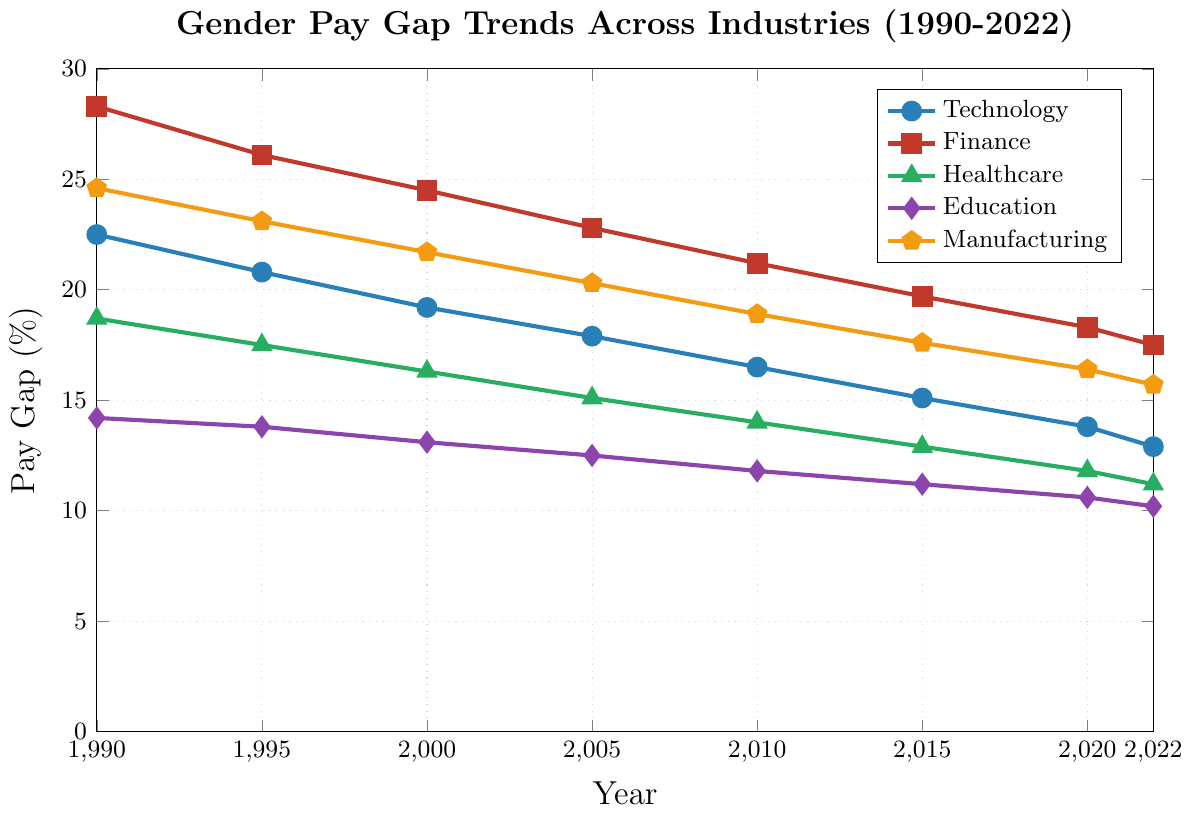What is the trend of the gender pay gap in the Technology industry from 1990 to 2022? The gender pay gap in the Technology industry shows a decreasing trend from 1990 to 2022. In 1990, the gap was 22.5%, which reduced to 12.9% in 2022. This indicates an improvement in closing the gender pay gap over the years.
Answer: Decreasing Which industry had the highest gender pay gap in 1990? By looking at the figure, the Finance industry had the highest gender pay gap in 1990 with a value of 28.3%.
Answer: Finance Compare the gender pay gap in the Education industry in 1990 and 2022. What is the difference? The gender pay gap in the Education industry was 14.2% in 1990 and 10.2% in 2022. The difference between these two values is 14.2% - 10.2% = 4.0%.
Answer: 4.0% Which industry shows the most significant reduction in the gender pay gap from 1990 to 2022? To find the industry with the most significant reduction, we need to subtract the 2022 value from the 1990 value for each industry. 
- Technology: 22.5% - 12.9% = 9.6%
- Finance: 28.3% - 17.5% = 10.8%
- Healthcare: 18.7% - 11.2% = 7.5%
- Education: 14.2% - 10.2% = 4.0%
- Manufacturing: 24.6% - 15.7% = 8.9%
Finance shows the most significant reduction in the gender pay gap with a decrease of 10.8%.
Answer: Finance What was the average gender pay gap across all industries in the year 2000? To find the average gender pay gap in 2000, sum the values for each industry and divide by the number of industries: (19.2 + 24.5 + 16.3 + 13.1 + 21.7) / 5 = 94.8 / 5 = 18.96%.
Answer: 18.96% How does the gender pay gap in Healthcare in 2000 compare with that in Manufacturing in 2010? In 2000, the gender pay gap in Healthcare was 16.3%, while in Manufacturing in 2010, it was 18.9%. Therefore, the gap in Manufacturing in 2010 was higher by 18.9% - 16.3% = 2.6%.
Answer: 2.6% higher in Manufacturing In which year did the Technology industry reach a gender pay gap of less than 20%? The gender pay gap in the Technology industry dropped below 20% in 2000, with a value of 19.2%.
Answer: 2000 How much did the gender pay gap in Finance decrease between 2010 and 2020? The gender pay gap in Finance was 21.2% in 2010 and 18.3% in 2020. The decrease can be calculated as 21.2% - 18.3% = 2.9%.
Answer: 2.9% Between 1990 and 2022, in which year did the Education industry experience the smallest gender pay gap? According to the figure, the smallest gender pay gap in the Education industry between 1990 and 2022 was in 2022, with a value of 10.2%.
Answer: 2022 